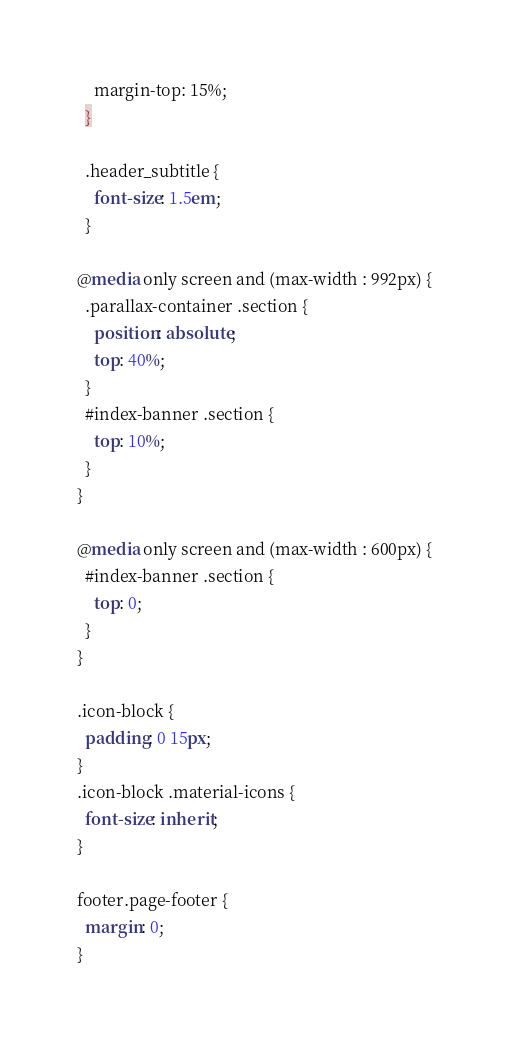<code> <loc_0><loc_0><loc_500><loc_500><_CSS_>    margin-top: 15%;
  }

  .header_subtitle {
    font-size: 1.5em;
  }

@media only screen and (max-width : 992px) {
  .parallax-container .section {
    position: absolute;
    top: 40%;
  }
  #index-banner .section {
    top: 10%;
  }
}

@media only screen and (max-width : 600px) {
  #index-banner .section {
    top: 0;
  }
}

.icon-block {
  padding: 0 15px;
}
.icon-block .material-icons {
  font-size: inherit;
}

footer.page-footer {
  margin: 0;
}
</code> 